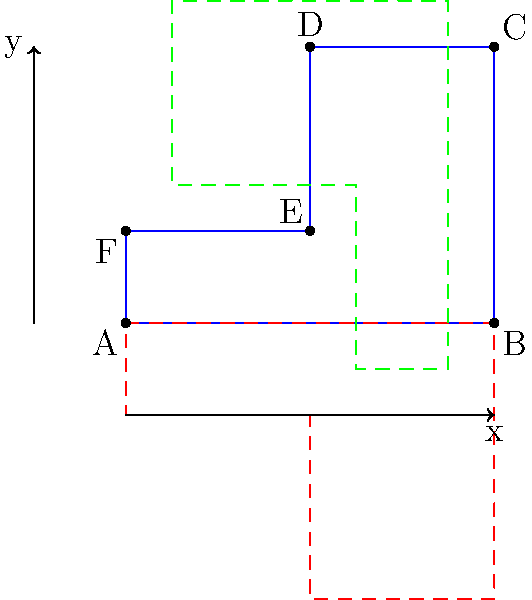In the diagram, the blue shape ABCDEF undergoes two transformations: a reflection across the x-axis (shown in red) and a 90-degree clockwise rotation around the point (2,1.5) (shown in green). After these transformations, how many lines of symmetry does the resulting composite figure have? To determine the number of lines of symmetry in the composite figure, let's follow these steps:

1) First, we need to visualize the composite figure, which consists of three shapes:
   - The original blue shape
   - The red shape (reflection across x-axis)
   - The green shape (90-degree clockwise rotation)

2) Now, let's consider potential lines of symmetry:

   a) Vertical line through the center:
      - This would split the blue and red shapes equally
      - The green shape would be split, but not symmetrically
      - Therefore, this is not a line of symmetry

   b) Horizontal line (x-axis):
      - This is the line of reflection for the red shape
      - It splits the blue and red shapes symmetrically
      - However, the green shape is not symmetric about this line
      - Thus, this is not a line of symmetry

   c) Diagonal lines:
      - Due to the irregular shape and the different orientations of the three components, there are no diagonal lines of symmetry

3) After considering all possibilities, we can conclude that the composite figure has no lines of symmetry.

The lack of symmetry is due to the asymmetric nature of the original shape and the different transformations applied, which create a complex, asymmetric composite figure.
Answer: 0 